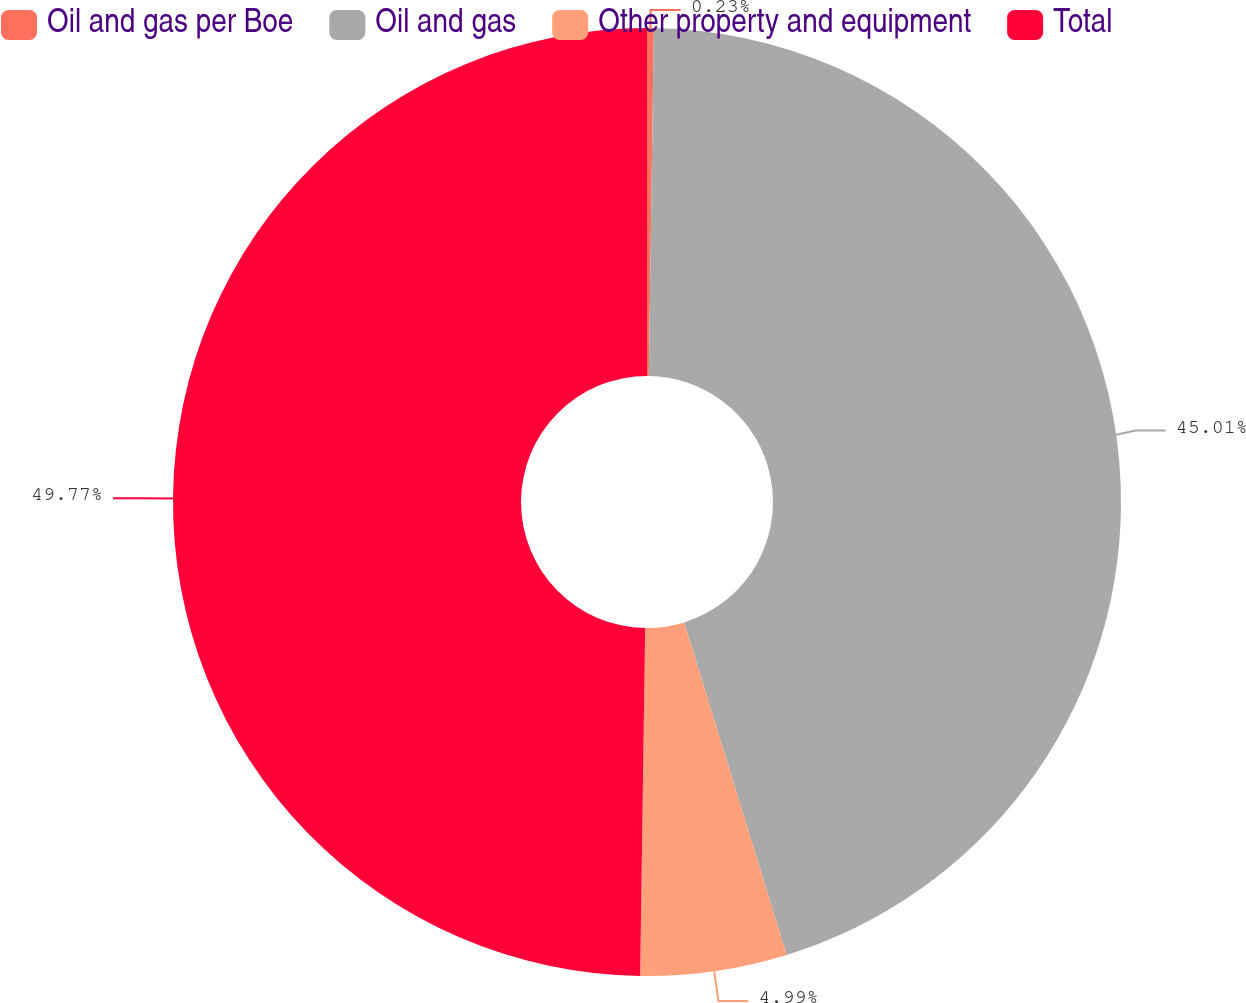Convert chart. <chart><loc_0><loc_0><loc_500><loc_500><pie_chart><fcel>Oil and gas per Boe<fcel>Oil and gas<fcel>Other property and equipment<fcel>Total<nl><fcel>0.23%<fcel>45.01%<fcel>4.99%<fcel>49.77%<nl></chart> 